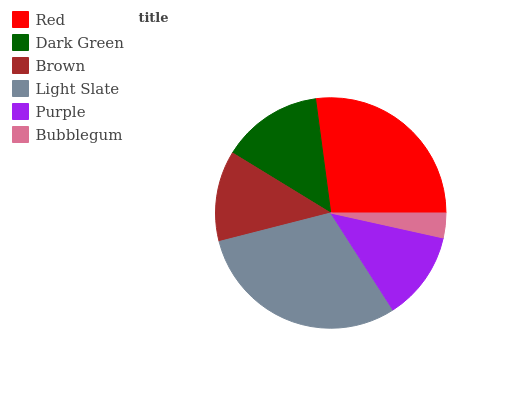Is Bubblegum the minimum?
Answer yes or no. Yes. Is Light Slate the maximum?
Answer yes or no. Yes. Is Dark Green the minimum?
Answer yes or no. No. Is Dark Green the maximum?
Answer yes or no. No. Is Red greater than Dark Green?
Answer yes or no. Yes. Is Dark Green less than Red?
Answer yes or no. Yes. Is Dark Green greater than Red?
Answer yes or no. No. Is Red less than Dark Green?
Answer yes or no. No. Is Dark Green the high median?
Answer yes or no. Yes. Is Brown the low median?
Answer yes or no. Yes. Is Red the high median?
Answer yes or no. No. Is Purple the low median?
Answer yes or no. No. 